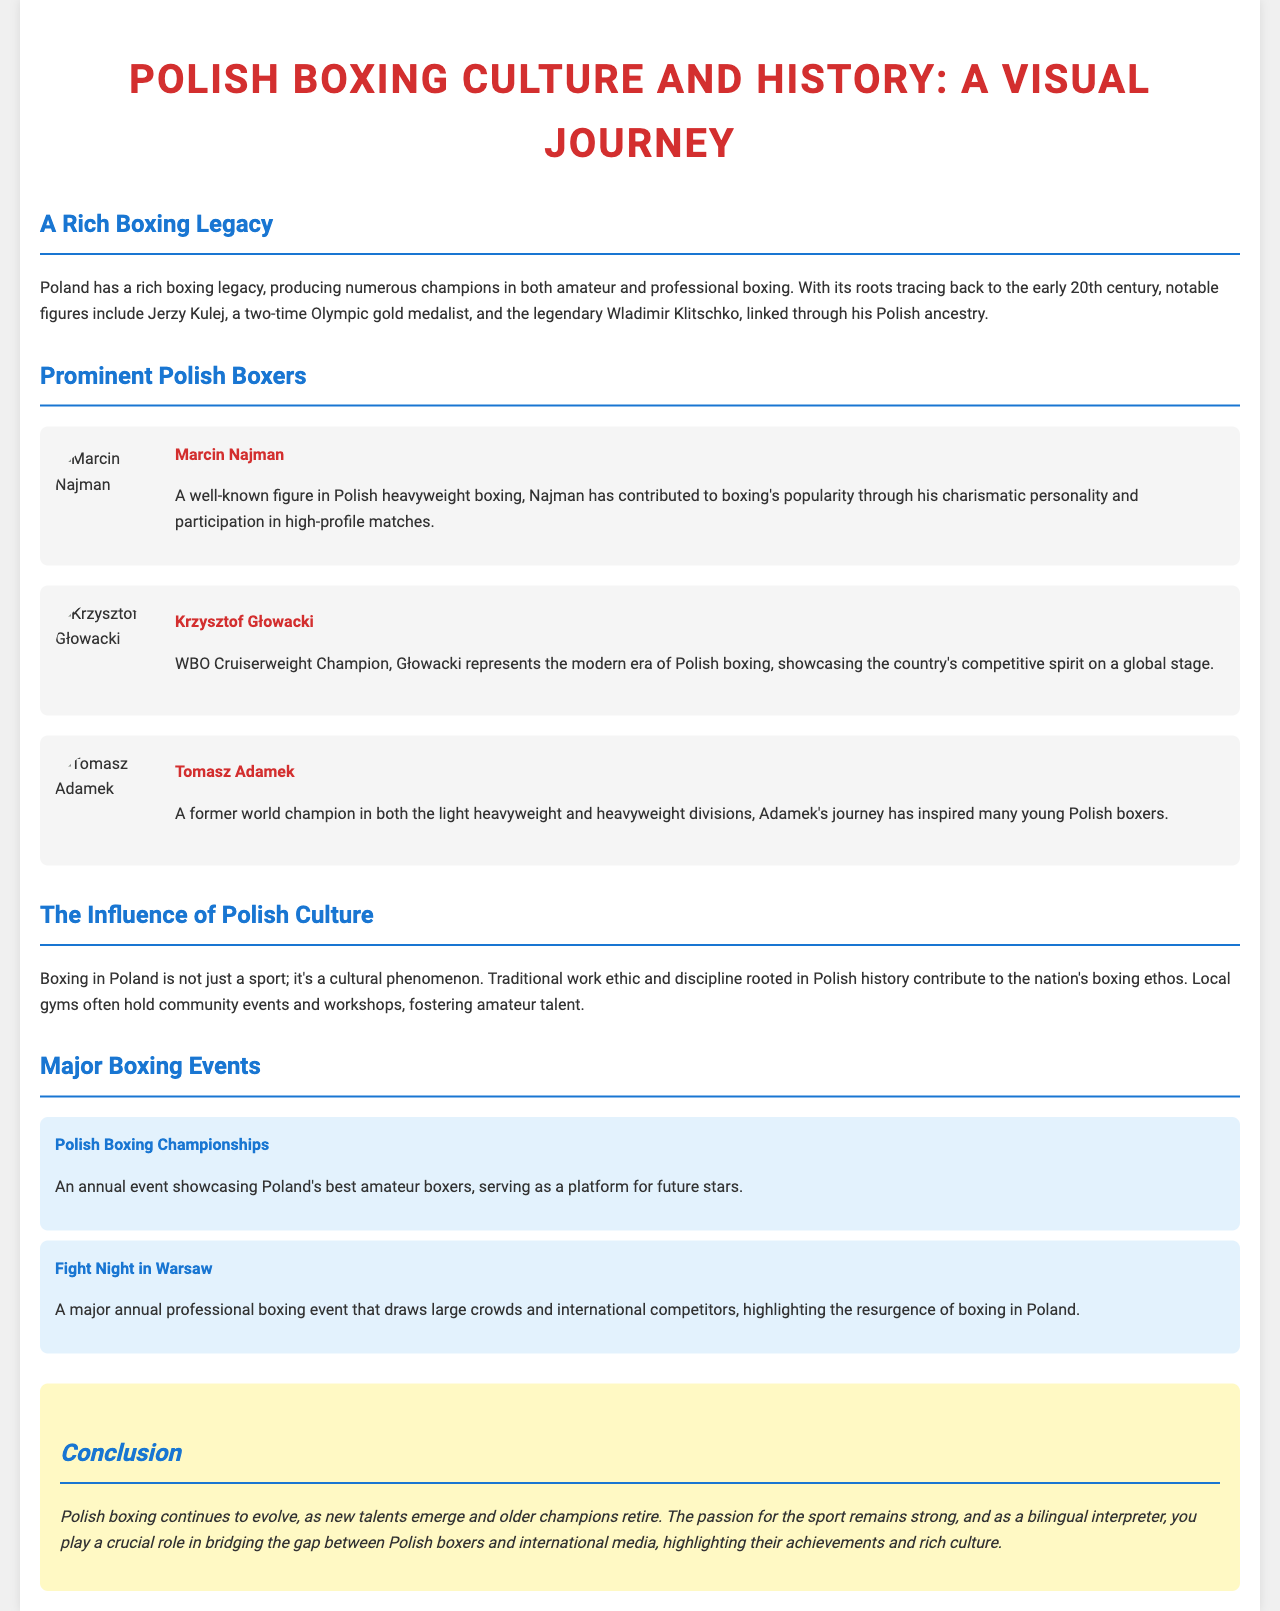What is the title of the document? The title is displayed prominently at the top of the document, summarizing its focus on Polish boxing culture and history.
Answer: Polish Boxing Culture and History: A Visual Journey Who is a two-time Olympic gold medalist mentioned in the document? The document specifically highlights Jerzy Kulej as a significant figure with this achievement in Polish boxing history.
Answer: Jerzy Kulej Which boxer is the WBO Cruiserweight Champion? The document identifies Krzysztof Głowacki as the current representation of this title in Polish boxing.
Answer: Krzysztof Głowacki What major annual professional boxing event is held in Warsaw? The document mentions this event as a significant occasion for boxing and fan engagement, specifically titled in the text.
Answer: Fight Night in Warsaw What does boxing in Poland represent beyond being a sport? The document describes boxing as part of the cultural fabric and societal influence in Poland, suggesting its broader significance.
Answer: A cultural phenomenon How does the document describe Tomasz Adamek? The document notes his achievements as a former world champion in specific weight divisions, emphasizing his inspirational role.
Answer: A former world champion in both the light heavyweight and heavyweight divisions What is the annual event that showcases Poland's best amateur boxers? The document specifically names this event and describes its function in promoting emerging boxing talent.
Answer: Polish Boxing Championships What characteristic of Polish culture influences boxing? The document attributes traditional aspects of work ethic and discipline as foundational to the boxing culture in Poland.
Answer: Traditional work ethic and discipline 